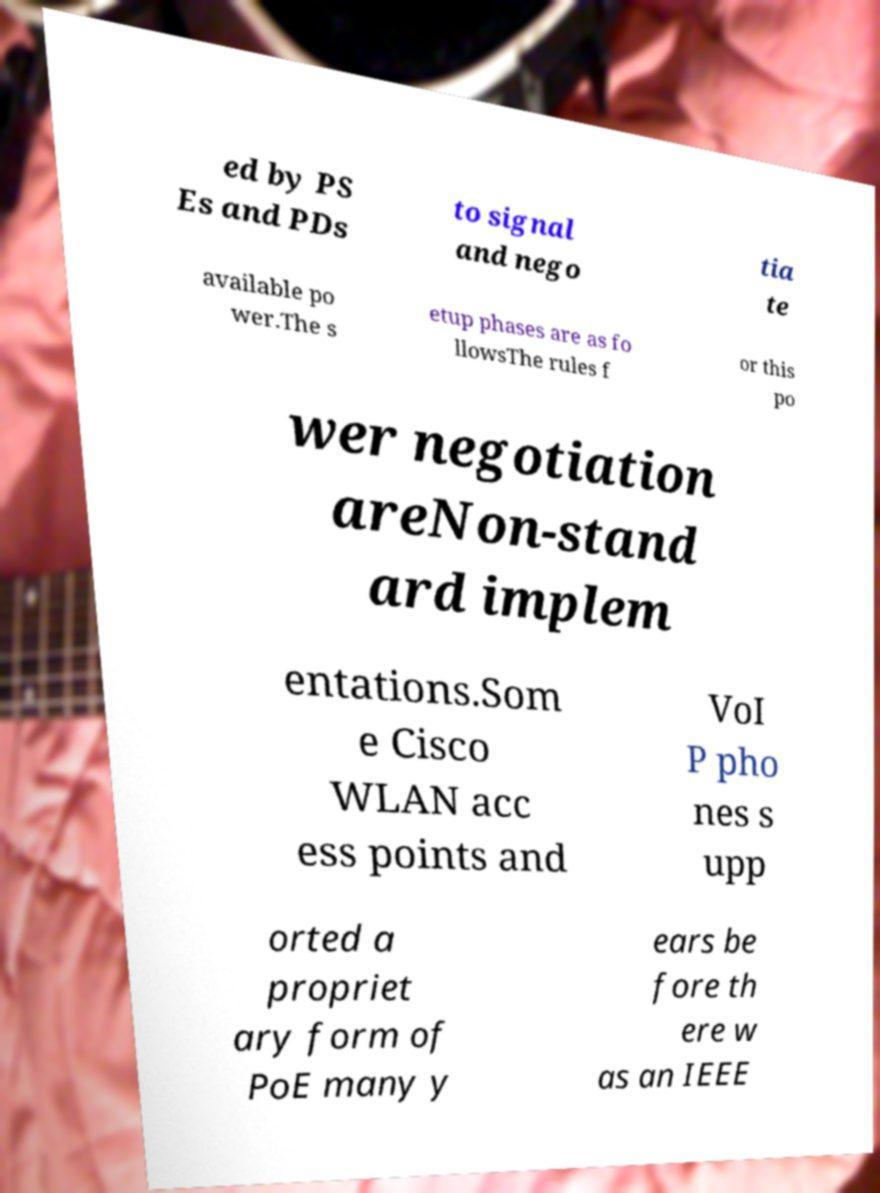Please identify and transcribe the text found in this image. ed by PS Es and PDs to signal and nego tia te available po wer.The s etup phases are as fo llowsThe rules f or this po wer negotiation areNon-stand ard implem entations.Som e Cisco WLAN acc ess points and VoI P pho nes s upp orted a propriet ary form of PoE many y ears be fore th ere w as an IEEE 